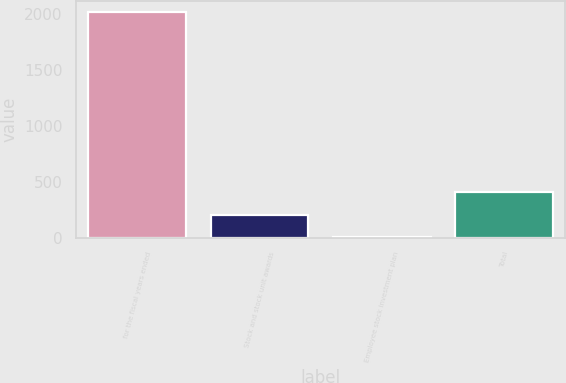Convert chart to OTSL. <chart><loc_0><loc_0><loc_500><loc_500><bar_chart><fcel>for the fiscal years ended<fcel>Stock and stock unit awards<fcel>Employee stock investment plan<fcel>Total<nl><fcel>2016<fcel>207.18<fcel>6.2<fcel>408.16<nl></chart> 